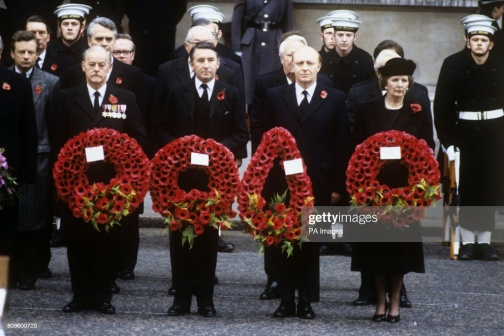Can you describe the atmosphere and setting of the image in detail? The image exudes a solemn and respectful atmosphere, characteristic of a memorial service. The setting appears to be outdoors, in front of a gray building with a stark, functional design that features windows and a black railing. This austere backdrop contrasts sharply with the vibrant red wreaths held by the participants. The vivid red poppy flowers in the wreaths symbolize remembrance and are a central visual element in the image. The individuals, all dressed in formal black attire or military uniforms, stand in a straight line, their serious expressions and composed demeanor enhancing the gravity of the scene. The overall mood is one of reflection and honor, as the group collectively participates in an act of remembrance. What might be the significance of the different ribbon colors on the wreaths? The different ribbon colors on the wreaths could signify various aspects or distinctions within the memorial being observed. While most of the wreaths have red ribbons, symbolizing remembrance and respect, the wreath with the yellow ribbon may indicate a special tribute. This could represent a specific unit or group, possibly denoting a different branch of the military, a unique commemoration, or honoring a particular individual or event within the broader memorial context. The variation in ribbon color adds a layer of meaning, highlighting the myriad ways in which memory and tribute are expressed. 